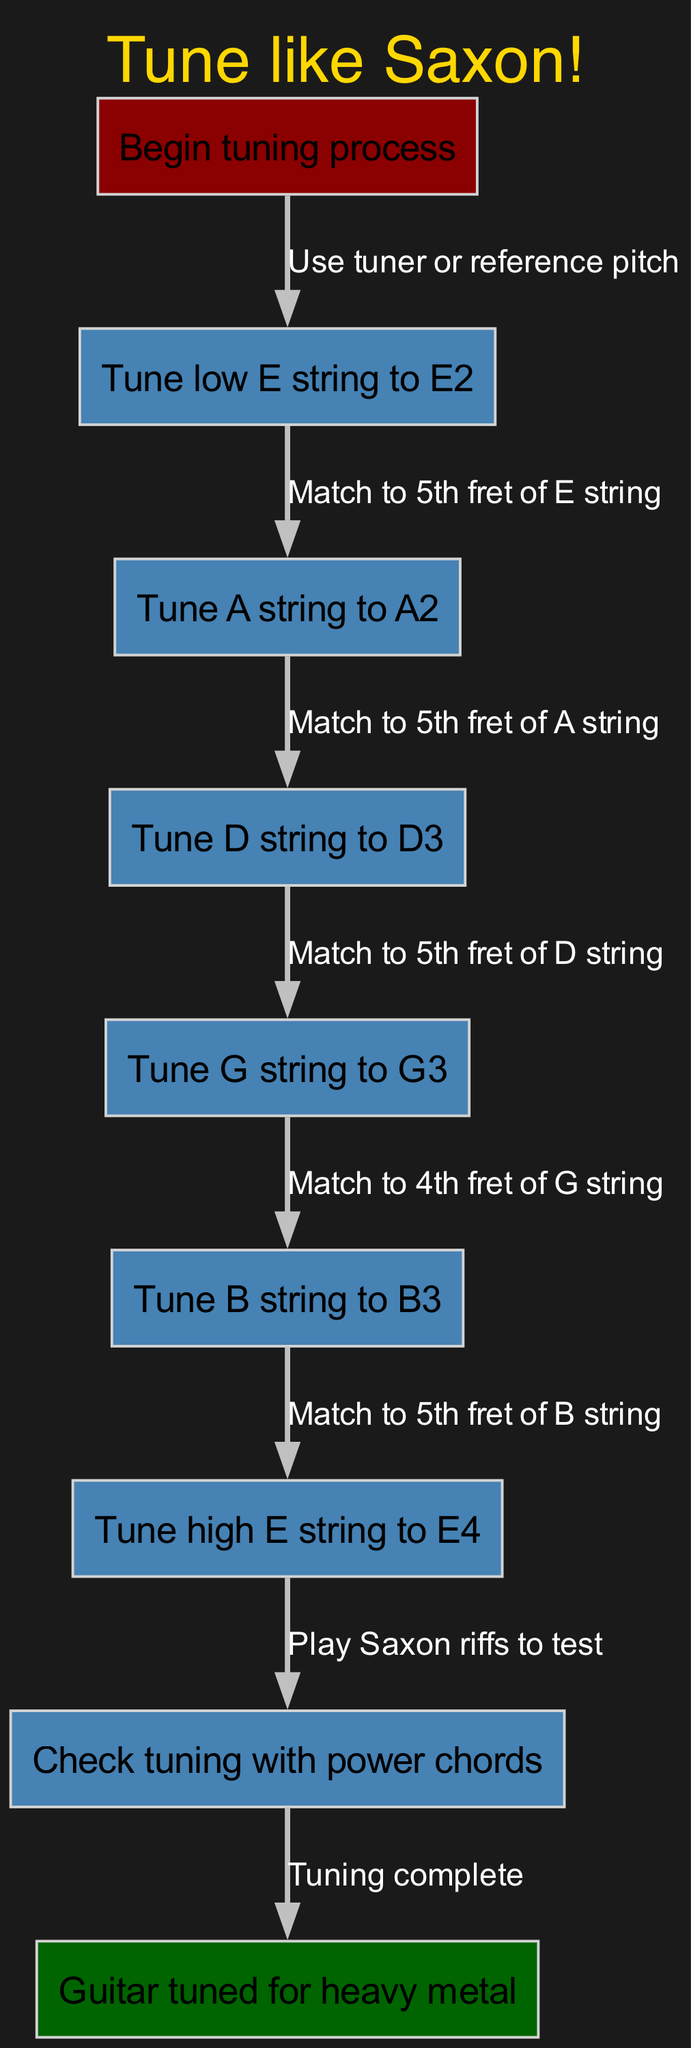What is the first step in tuning the guitar? The diagram starts with "Tune low E string to E2" as the first step.
Answer: Tune low E string to E2 How many steps are involved in the tuning process? The diagram lists a total of six steps, each detailing the tuning of different guitar strings.
Answer: Six steps What string should be tuned after the low E string? Following the low E string, the next step is to tune the A string to A2.
Answer: Tune A string to A2 What method is used to tune the B string? The B string is tuned by matching it to the 4th fret of the G string, as indicated in the corresponding step.
Answer: Match to 4th fret of G string What is the final node in the flow chart? The last node in the flow chart signifies the completion of the tuning process, stating "Guitar tuned for heavy metal."
Answer: Guitar tuned for heavy metal Which string is matched to the 5th fret of the B string? According to the flow, the high E string is matched to the 5th fret of the B string as its tuning step.
Answer: Tune high E string to E4 What action is suggested to check the tuning? To verify the tuning, it is recommended to "Check tuning with power chords" by playing Saxon riffs.
Answer: Play Saxon riffs to test Which step involves the D string? The third step in the sequence details tuning the D string to D3 by matching it to the 5th fret of the A string.
Answer: Tune D string to D3 Which edge connects the start node to the first step? The edge connecting the start node to the first step states "Use tuner or reference pitch."
Answer: Use tuner or reference pitch 